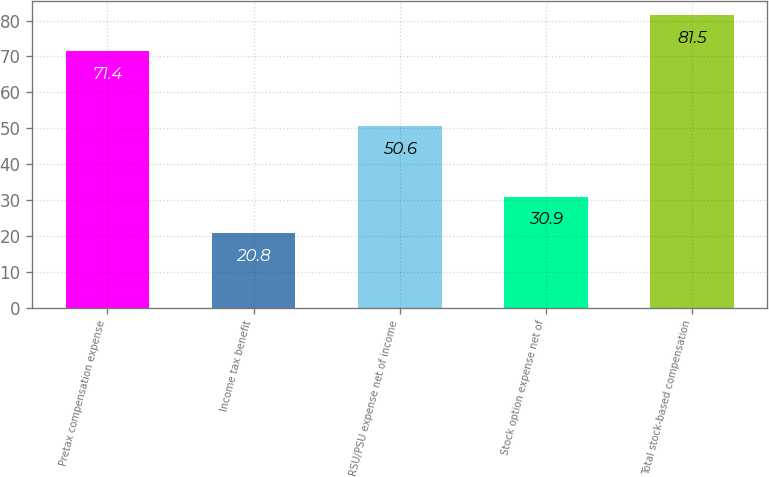Convert chart to OTSL. <chart><loc_0><loc_0><loc_500><loc_500><bar_chart><fcel>Pretax compensation expense<fcel>Income tax benefit<fcel>RSU/PSU expense net of income<fcel>Stock option expense net of<fcel>Total stock-based compensation<nl><fcel>71.4<fcel>20.8<fcel>50.6<fcel>30.9<fcel>81.5<nl></chart> 